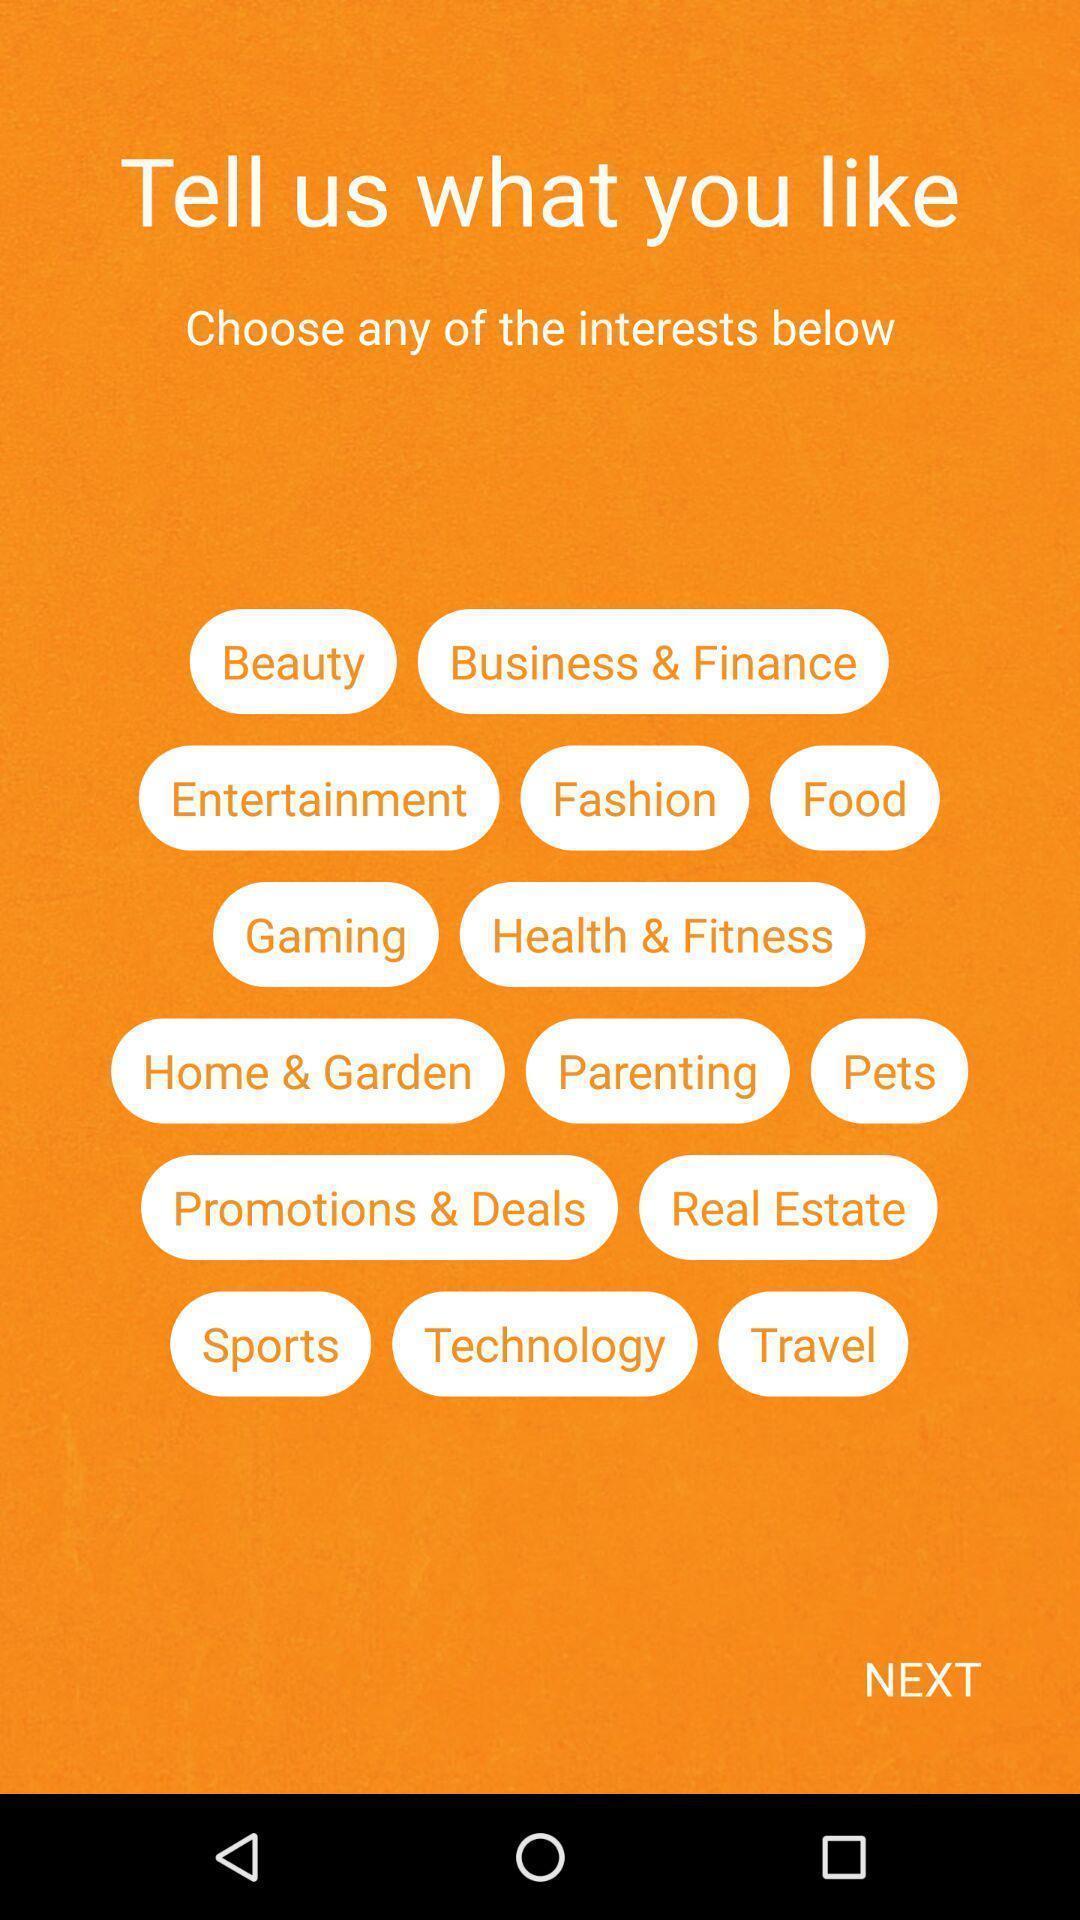What can you discern from this picture? Screen shows to choose any of the interests. 